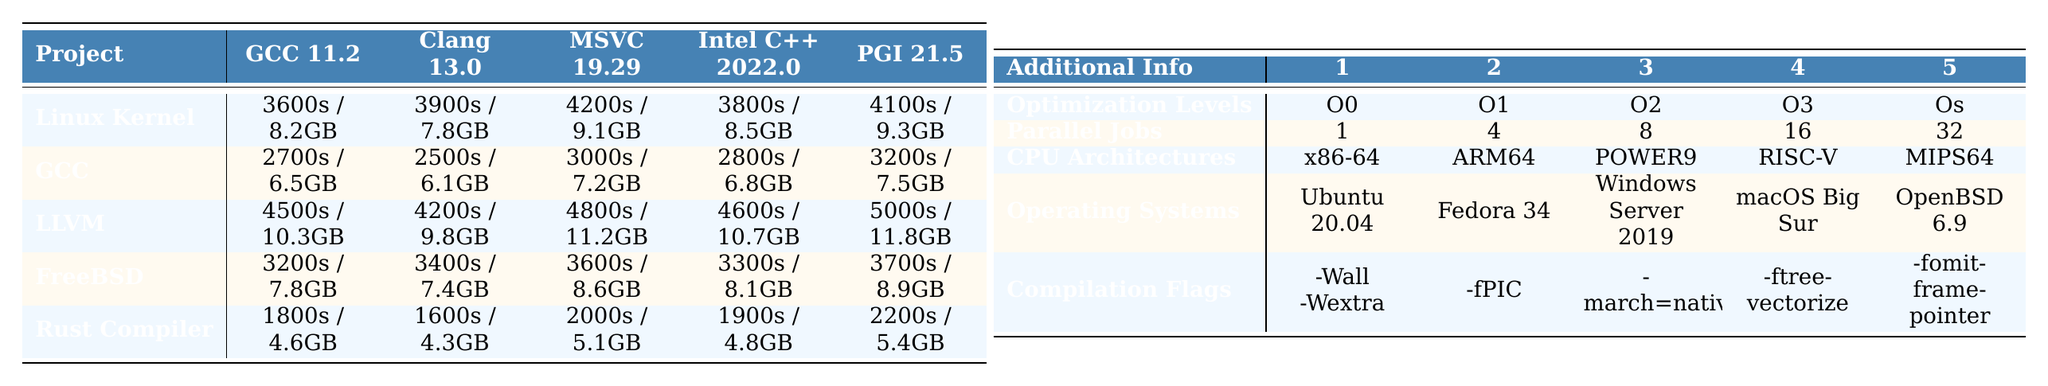What is the compilation time of the Rust Compiler using Clang 13.0? Referring to the table, the compilation time of the Rust Compiler using Clang 13.0 is 1600 seconds.
Answer: 1600 seconds Which project has the highest memory usage with GCC 11.2? Looking at the GCC 11.2 column, LLVM shows the highest memory usage at 10.3 GB.
Answer: LLVM What is the sum of compilation times for the Linux Kernel across all compilers? The compilation times for the Linux Kernel are 3600, 3900, 4200, 3800, and 4100 seconds. Adding these times gives 3600 + 3900 + 4200 + 3800 + 4100 = 19600 seconds.
Answer: 19600 seconds Is the compilation time of FreeBSD with Intel C++ Compiler less than 3500 seconds? The compilation time for FreeBSD with Intel C++ Compiler is 3300 seconds, which is indeed less than 3500 seconds.
Answer: Yes What is the average compilation time of the GCC project with all compilers? The compilation times for the GCC project are 2700, 2500, 3000, 2800, and 3200 seconds. The sum is 2700 + 2500 + 3000 + 2800 + 3200 = 14000 seconds, and averaging this over 5 gives 14000/5 = 2800 seconds.
Answer: 2800 seconds Which compiler has the lowest memory usage when compiling the Rust Compiler? The memory usage for the Rust Compiler shows that Clang 13.0 has the lowest usage at 4.3 GB.
Answer: Clang 13.0 What is the maximum compilation time recorded for the LLVM project across all compilers? By examining the LLVM row, the maximum compilation time recorded is 5000 seconds with PGI Compiler 21.5.
Answer: 5000 seconds Does the operating system used affect the compilation times across projects? The table shows that different compilation times are recorded for the same projects across different operating systems, indicating that the operating system does affect compilation times.
Answer: Yes What is the least amount of memory used when compiling any of the projects with GCC 11.2? Referring to the memory usage column for GCC 11.2, the least memory used is 6.1 GB for the GDC project.
Answer: 6.1 GB How does the compilation time of FreeBSD with O3 optimization compare to the Linux Kernel with O0 optimization? For FreeBSD, the time with O3 optimization is 3300 seconds, and for the Linux Kernel with O0 optimization, it is 3600 seconds. Therefore, FreeBSD has a shorter compilation time by 3600 - 3300 = 300 seconds.
Answer: FreeBSD is faster by 300 seconds 